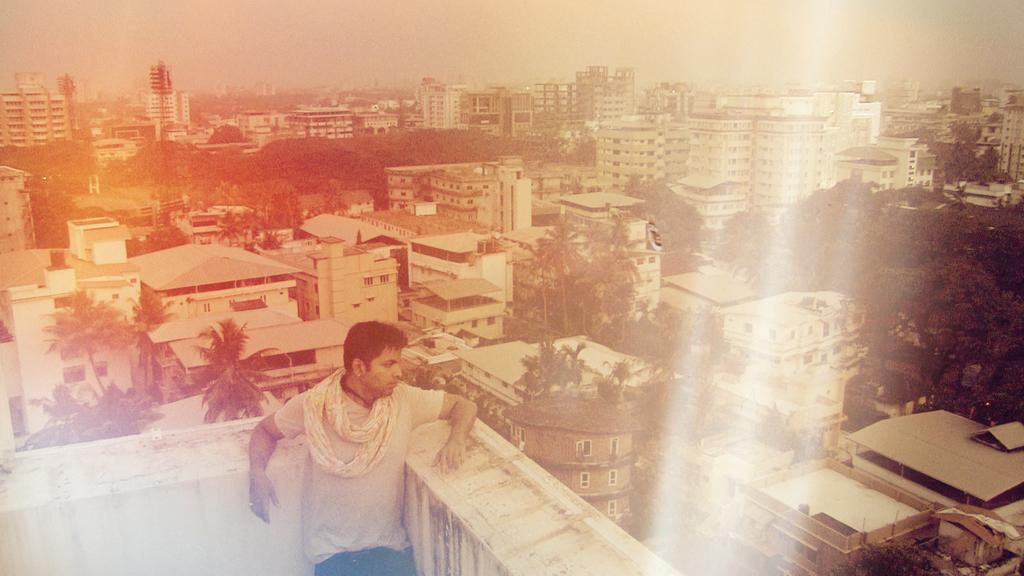What is the man in the image doing? The man is standing on a building in the image. What type of natural elements can be seen in the image? There are trees visible in the image. What type of structures are present in the image? There are buildings in the image. What can be seen on the towers in the image? There are lights on the towers in the image. Can you see any clams on the island in the image? There is no island present in the image, and therefore no clams can be seen. 